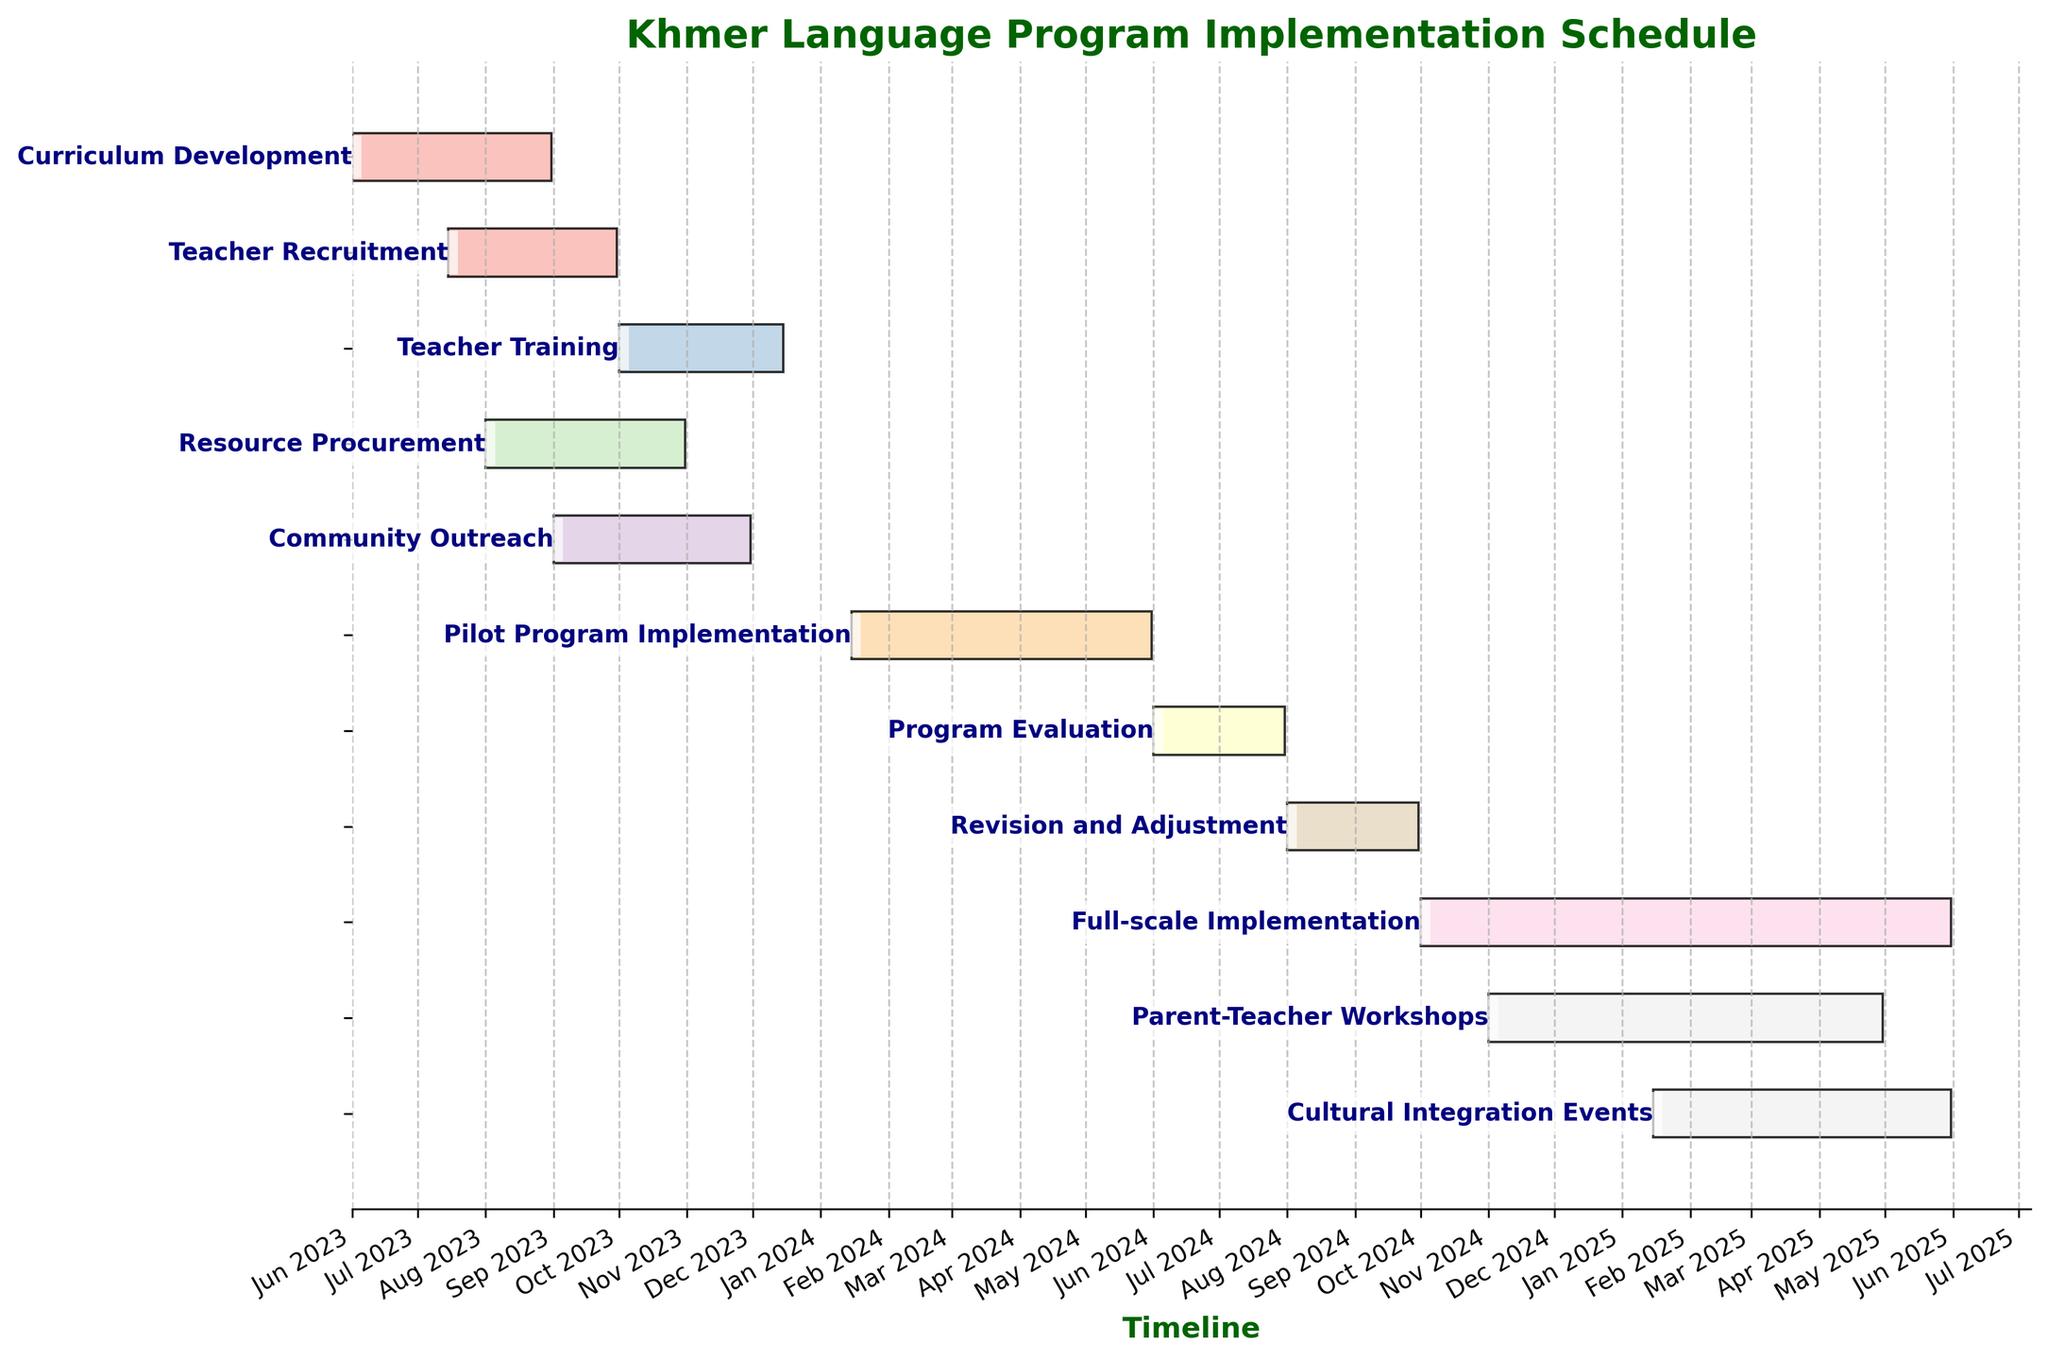What's the duration of the Pilot Program Implementation task? The Gantt chart provides both start and end dates for each task. For the Pilot Program Implementation, it starts on January 15, 2024, and ends on May 31, 2024. The duration is provided as 138 days.
Answer: 138 days When does the Teacher Training task start and end? Teacher Training is marked on the Gantt chart with its own bar. By reading the text next to the bar, we see that it starts on October 1, 2023, and ends on December 15, 2023.
Answer: Starts: October 1, 2023; Ends: December 15, 2023 Which task has the shortest duration? The Gantt chart shows the duration of each task in days. By comparing the durations, we find that Program Evaluation and Revision and Adjustment both have 61 days, making them the tasks with the shortest duration.
Answer: Program Evaluation and Revision and Adjustment (both) How many tasks are scheduled to occur in 2024? From the chart, we identify and count the tasks occurring in 2024: Pilot Program Implementation, Program Evaluation, Revision and Adjustment, Full-scale Implementation, Parent-Teacher Workshops, and Cultural Integration Events. There are 6 tasks.
Answer: 6 tasks Which task overlaps entirely with the Community Outreach task? Community Outreach starts on September 1, 2023, and ends on November 30, 2023. Teacher Training (October 1, 2023 to December 15, 2023) and Resource Procurement (August 1, 2023 to October 31, 2023) overlap partially but none overlap entirely.
Answer: None When is the Full-scale Implementation scheduled to begin? The Full-scale Implementation task on the Gantt chart starts on October 1, 2024, as indicated by the label next to the corresponding bar.
Answer: October 1, 2024 Does the Resource Procurement task overlap with the Teacher Recruitment task? If yes, for how long? Yes, Resource Procurement starts on August 1, 2023, and ends on October 31, 2023. Teacher Recruitment starts on July 15, 2023, and ends on September 30, 2023. The overlap is from August 1, 2023, to September 30, 2023, which is 61 days.
Answer: Yes, 61 days Which tasks are scheduled during the summer months (June, July, August) of 2024? For the summer of 2024 (June, July, August), the chart shows that Program Evaluation (June 1 to July 31) and Revision and Adjustment (starting August 1) take place.
Answer: Program Evaluation and Revision and Adjustment How many tasks are overlapping with Full-scale Implementation? Full-scale Implementation (October 1, 2024, to May 31, 2025) overlaps with several tasks: Revision and Adjustment (October 1, 2024, to September 30, 2024), Parent-Teacher Workshops (November 1, 2024, to April 30, 2025), and Cultural Integration Events (January 15, 2025, to May 31, 2025). There are 3 such tasks.
Answer: 3 tasks 